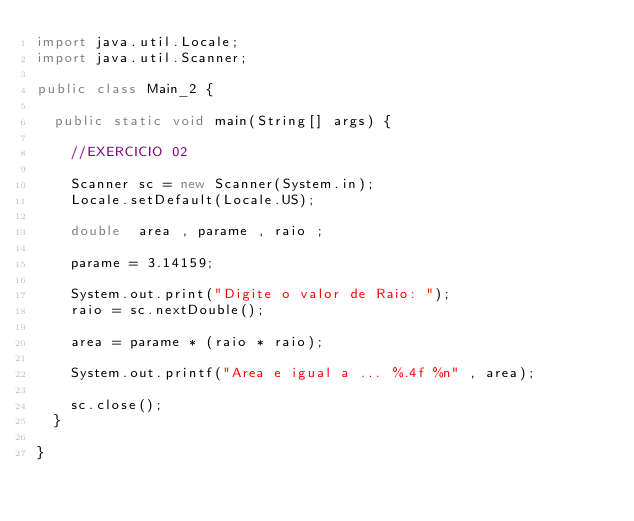Convert code to text. <code><loc_0><loc_0><loc_500><loc_500><_Java_>import java.util.Locale;
import java.util.Scanner;

public class Main_2 {

	public static void main(String[] args) {
		
		//EXERCICIO 02
		
		Scanner sc = new Scanner(System.in);
		Locale.setDefault(Locale.US);
		
		double  area , parame , raio ; 
		
		parame = 3.14159;
		
		System.out.print("Digite o valor de Raio: ");
		raio = sc.nextDouble();
		
		area = parame * (raio * raio);
		
		System.out.printf("Area e igual a ... %.4f %n" , area);
		
		sc.close();
	}

}
</code> 